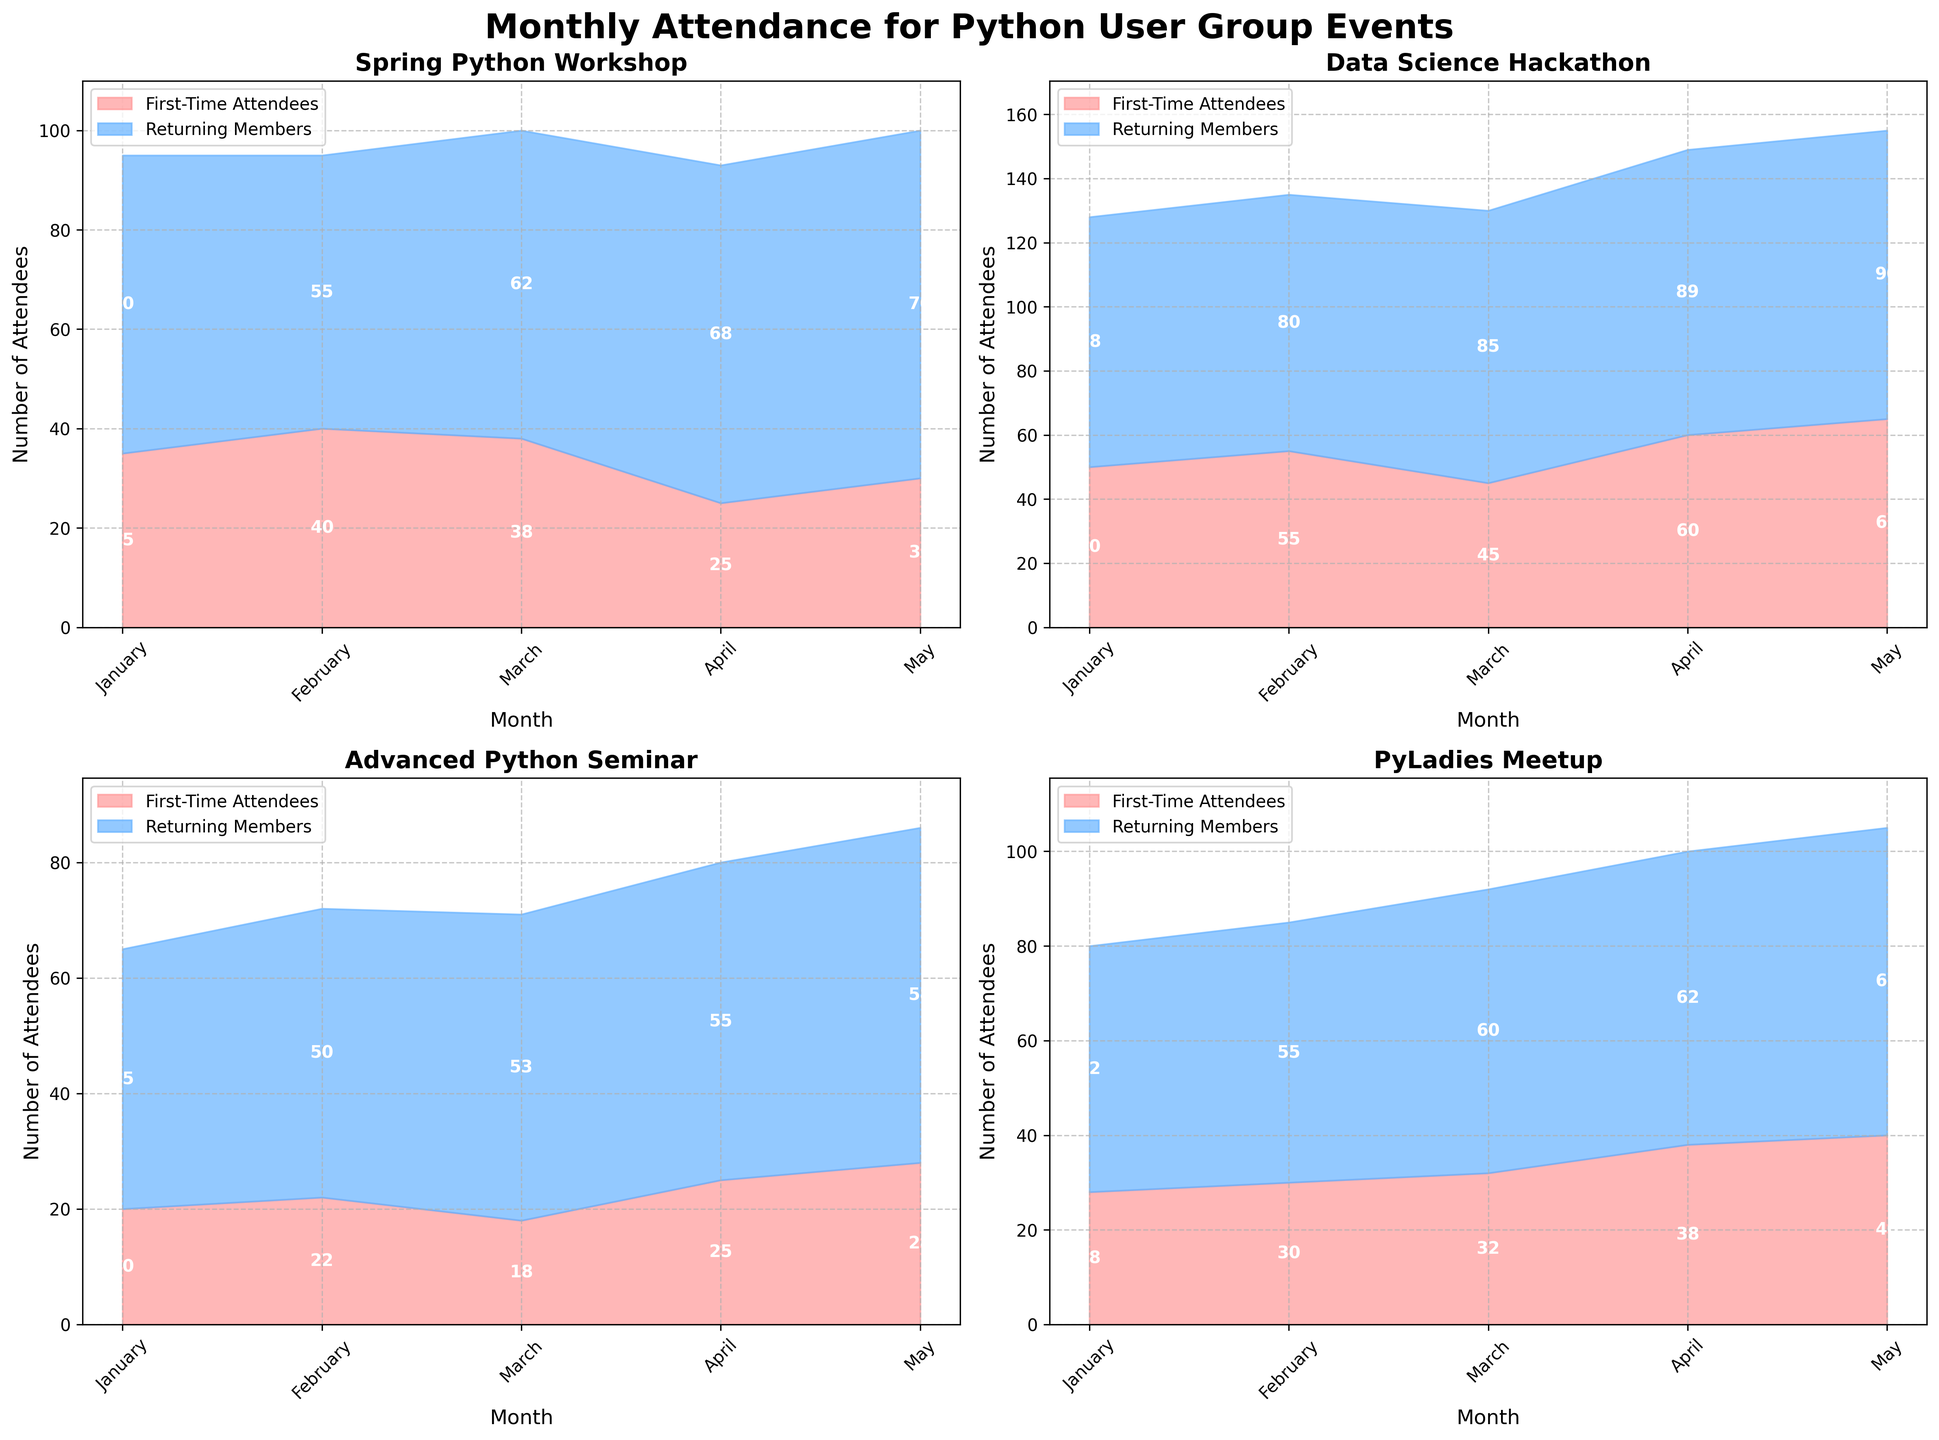What is the title of the figure? The title is usually placed at the top of the figure and provides an overview of what the figure is about. In this case, the title reads "Monthly Attendance for Python User Group Events".
Answer: Monthly Attendance for Python User Group Events Which event had the highest number of first-time attendees in May 2023? Look at the subplots for May 2023 to compare the first-time attendees across all events. The Data Science Hackathon had 65 first-time attendees in May 2023, which is the highest.
Answer: Data Science Hackathon Comparing the PyLadies Meetup and the Advanced Python Seminar, which had more returning members in April 2023? Looking at the subplots for April 2023, identify the number of returning members for both events. PyLadies Meetup had 62 returning members, while Advanced Python Seminar had 55.
Answer: PyLadies Meetup What is the total attendance for the Spring Python Workshop in February 2023? Add the number of first-time attendees and returning members for the Spring Python Workshop in February 2023. It is 40 (first-time) + 55 (returning) = 95.
Answer: 95 Which month had the lowest number of first-time attendees for any event? Look through each month's data for all events to find the month with the smallest value for first-time attendees. The Advanced Python Seminar in March 2023 had the lowest with 18 first-time attendees.
Answer: March 2023 How does the number of returning members in Data Science Hackathon compare from March to April 2023? Compare the number of returning members in the Data Science Hackathon subplot for March (85) and April (89). April has 4 more returning members than March.
Answer: April has 4 more What is the average number of first-time attendees across all events in January 2023? Add up the first-time attendees for all events in January 2023 and divide by the number of events: (35 + 50 + 20 + 28) / 4 = 33.25.
Answer: 33.25 Which event shows the most fluctuation in the number of first-time attendees over the months? Examine the first-time attendees across months for each event. Data Science Hackathon shows the highest range with numbers varying from 45 to 65.
Answer: Data Science Hackathon During which month did Spring Python Workshop have its highest number of returning members? Look at the subplot for Spring Python Workshop and identify the month with the highest value for returning members. May 2023 was the highest with 70 returning members.
Answer: May 2023 In which event and month did the sum of first-time attendees and returning members hit the highest value? Calculate the sum for each event and month. Data Science Hackathon in May 2023 has the highest sum with 65 (first-time) + 90 (returning) = 155.
Answer: Data Science Hackathon in May 2023 